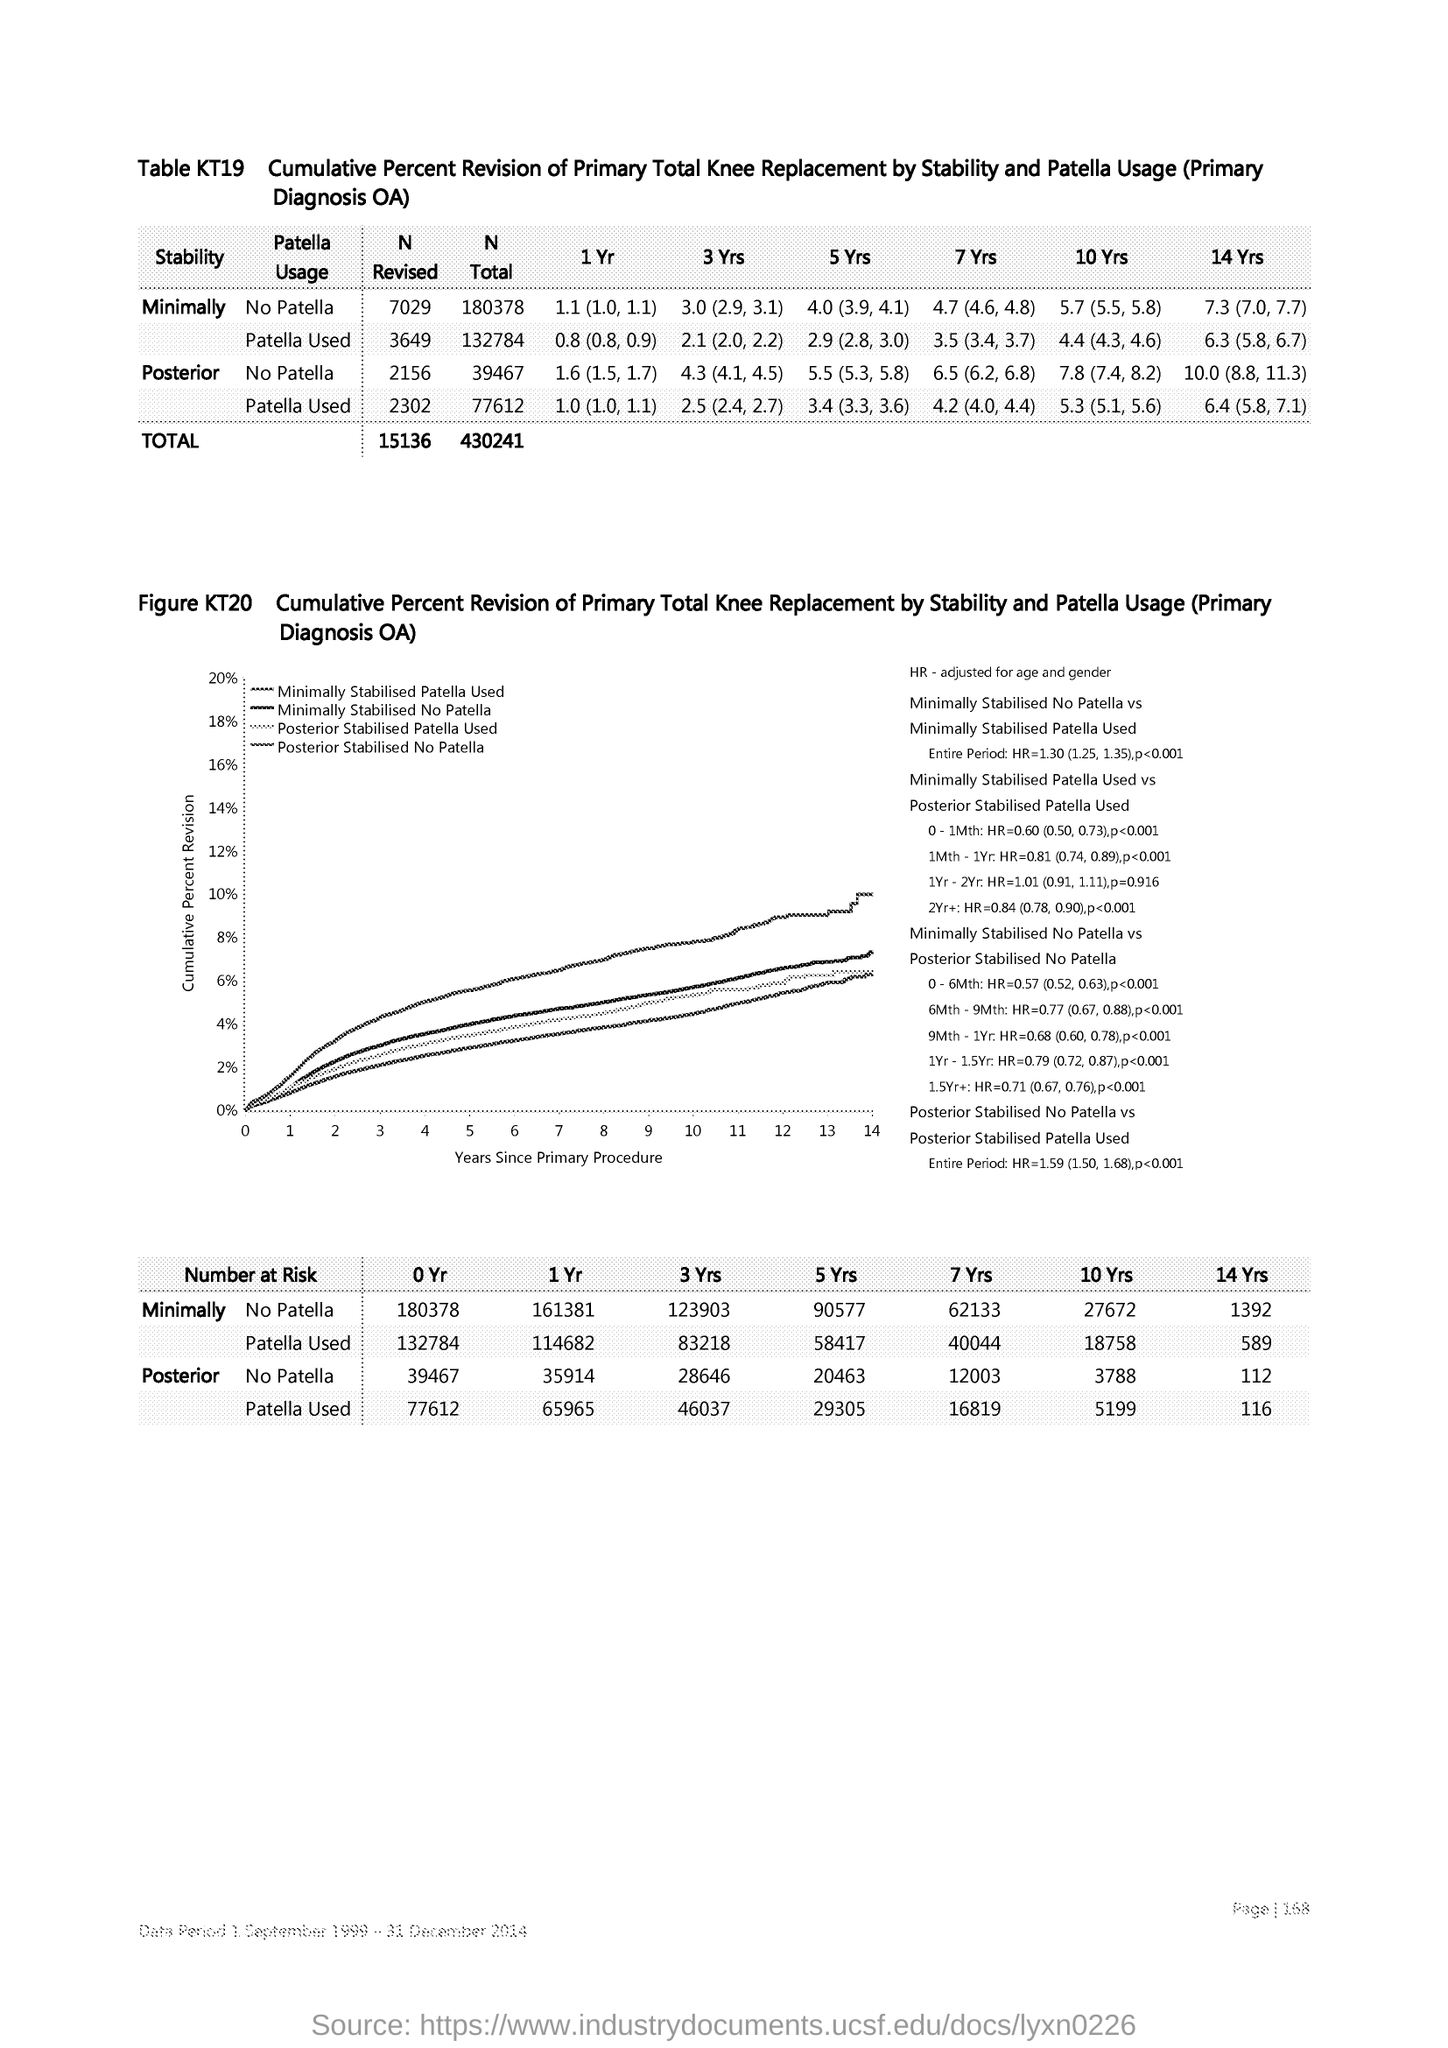Draw attention to some important aspects in this diagram. The cumulative percent revision is plotted on the y-axis in the chart. The x-axis shows the number of years that have passed since the patient underwent their primary procedure. 